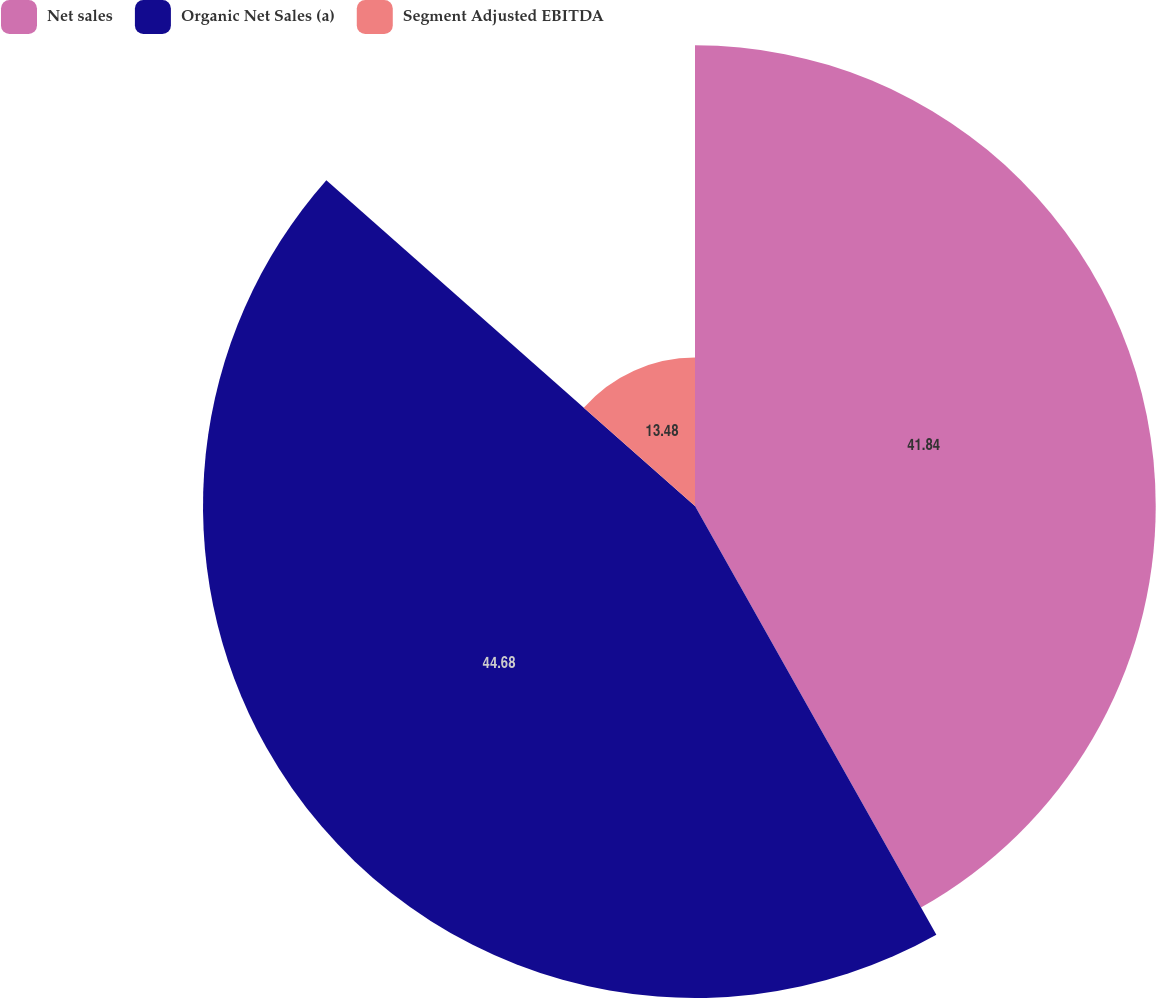<chart> <loc_0><loc_0><loc_500><loc_500><pie_chart><fcel>Net sales<fcel>Organic Net Sales (a)<fcel>Segment Adjusted EBITDA<nl><fcel>41.84%<fcel>44.68%<fcel>13.48%<nl></chart> 